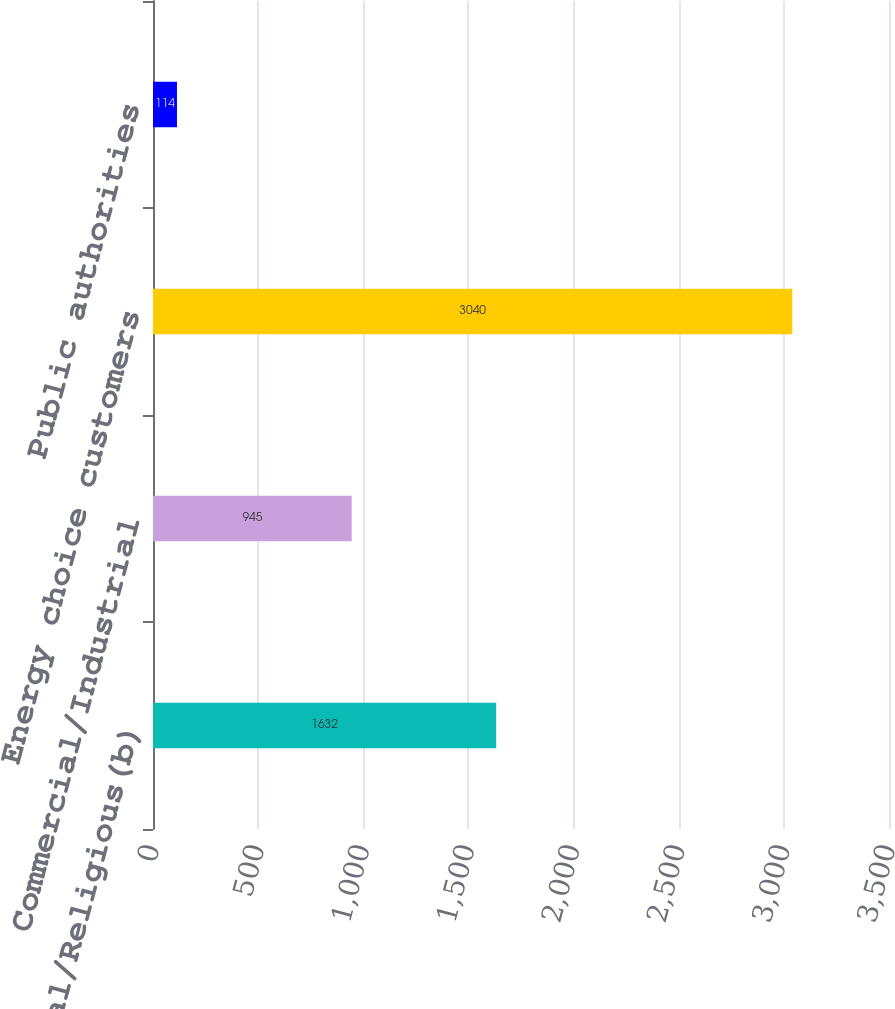Convert chart. <chart><loc_0><loc_0><loc_500><loc_500><bar_chart><fcel>Residential/Religious(b)<fcel>Commercial/Industrial<fcel>Energy choice customers<fcel>Public authorities<nl><fcel>1632<fcel>945<fcel>3040<fcel>114<nl></chart> 